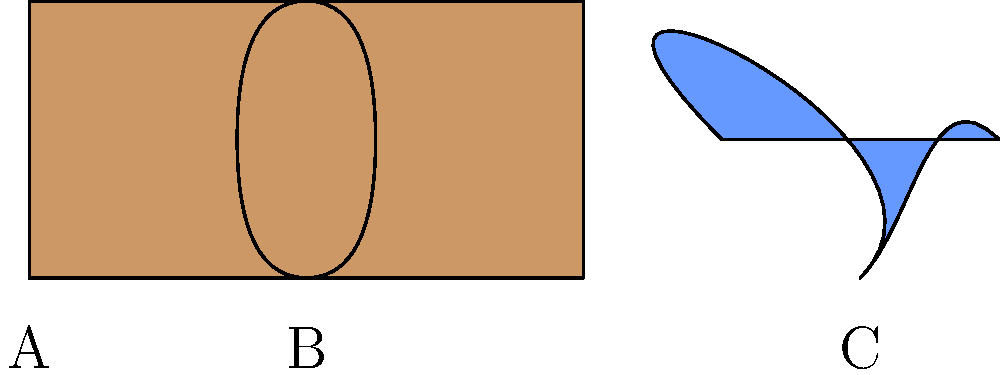In the image above, three religious figures are represented by simplified shapes. Which shape (A, B, or C) most likely represents the Buddha, a central figure in Buddhism? To identify the shape representing Buddha, let's analyze each shape:

1. Shape A (left): A rectangular shape, which is not typically associated with Buddha representations.

2. Shape B (center): An oval or egg-like shape with a narrower bottom and wider top. This shape resembles the common seated meditation posture of Buddha statues.

3. Shape C (right): A curved shape with points, which is not characteristic of Buddha depictions.

Buddha is often portrayed in a seated meditation posture, with a rounded body shape. The oval or egg-like form of Shape B best represents this common depiction of Buddha.

In Buddhist art, Buddha is frequently shown with a serene, rounded figure, often in the lotus position or other meditative poses. The smooth, curved lines of Shape B align well with this artistic tradition.

Shape A might represent a more angular figure, while Shape C could be associated with deities from other religions that incorporate more dynamic or ornate forms.

Given the context of religious studies and the focus on recognizing religious figures through artistic depictions, Shape B is the most likely representation of Buddha among the given options.
Answer: B 